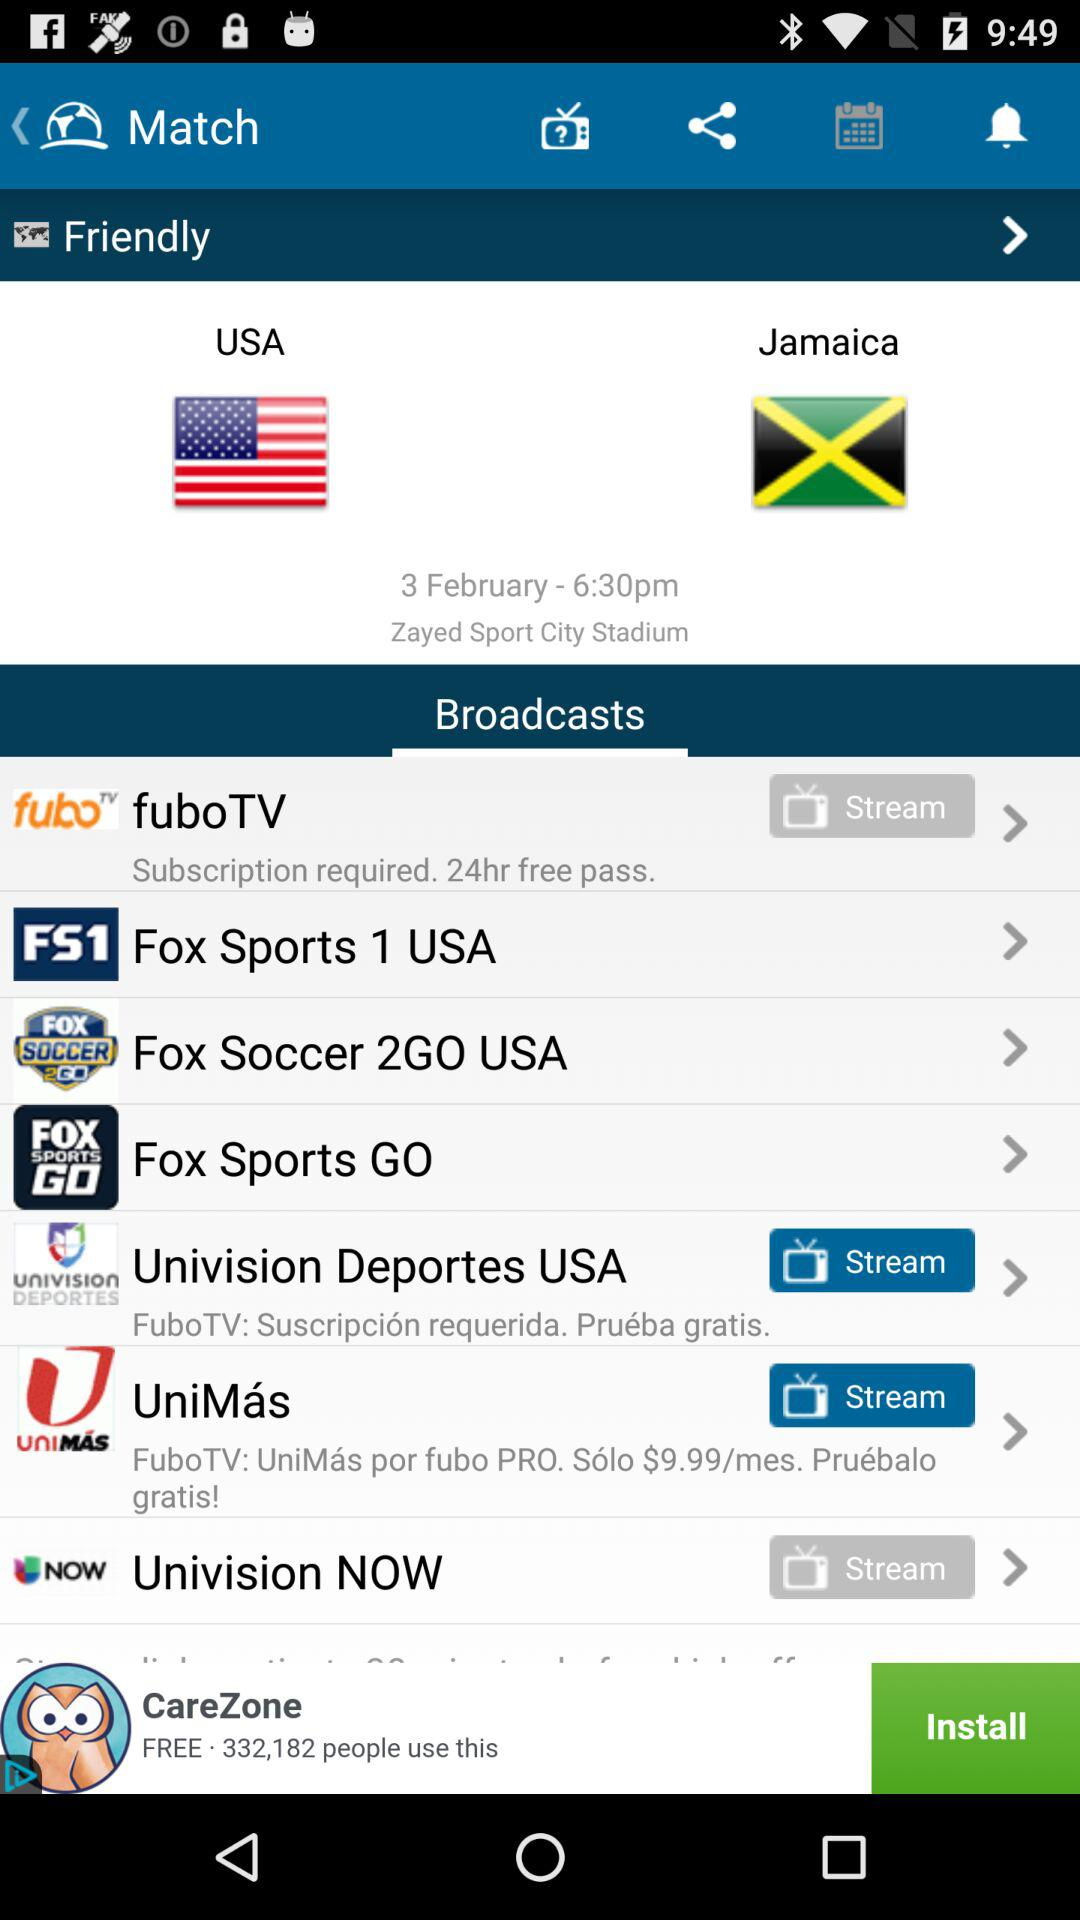What is the match time? The match time is 6:30 p.m. 